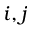Convert formula to latex. <formula><loc_0><loc_0><loc_500><loc_500>i , j</formula> 